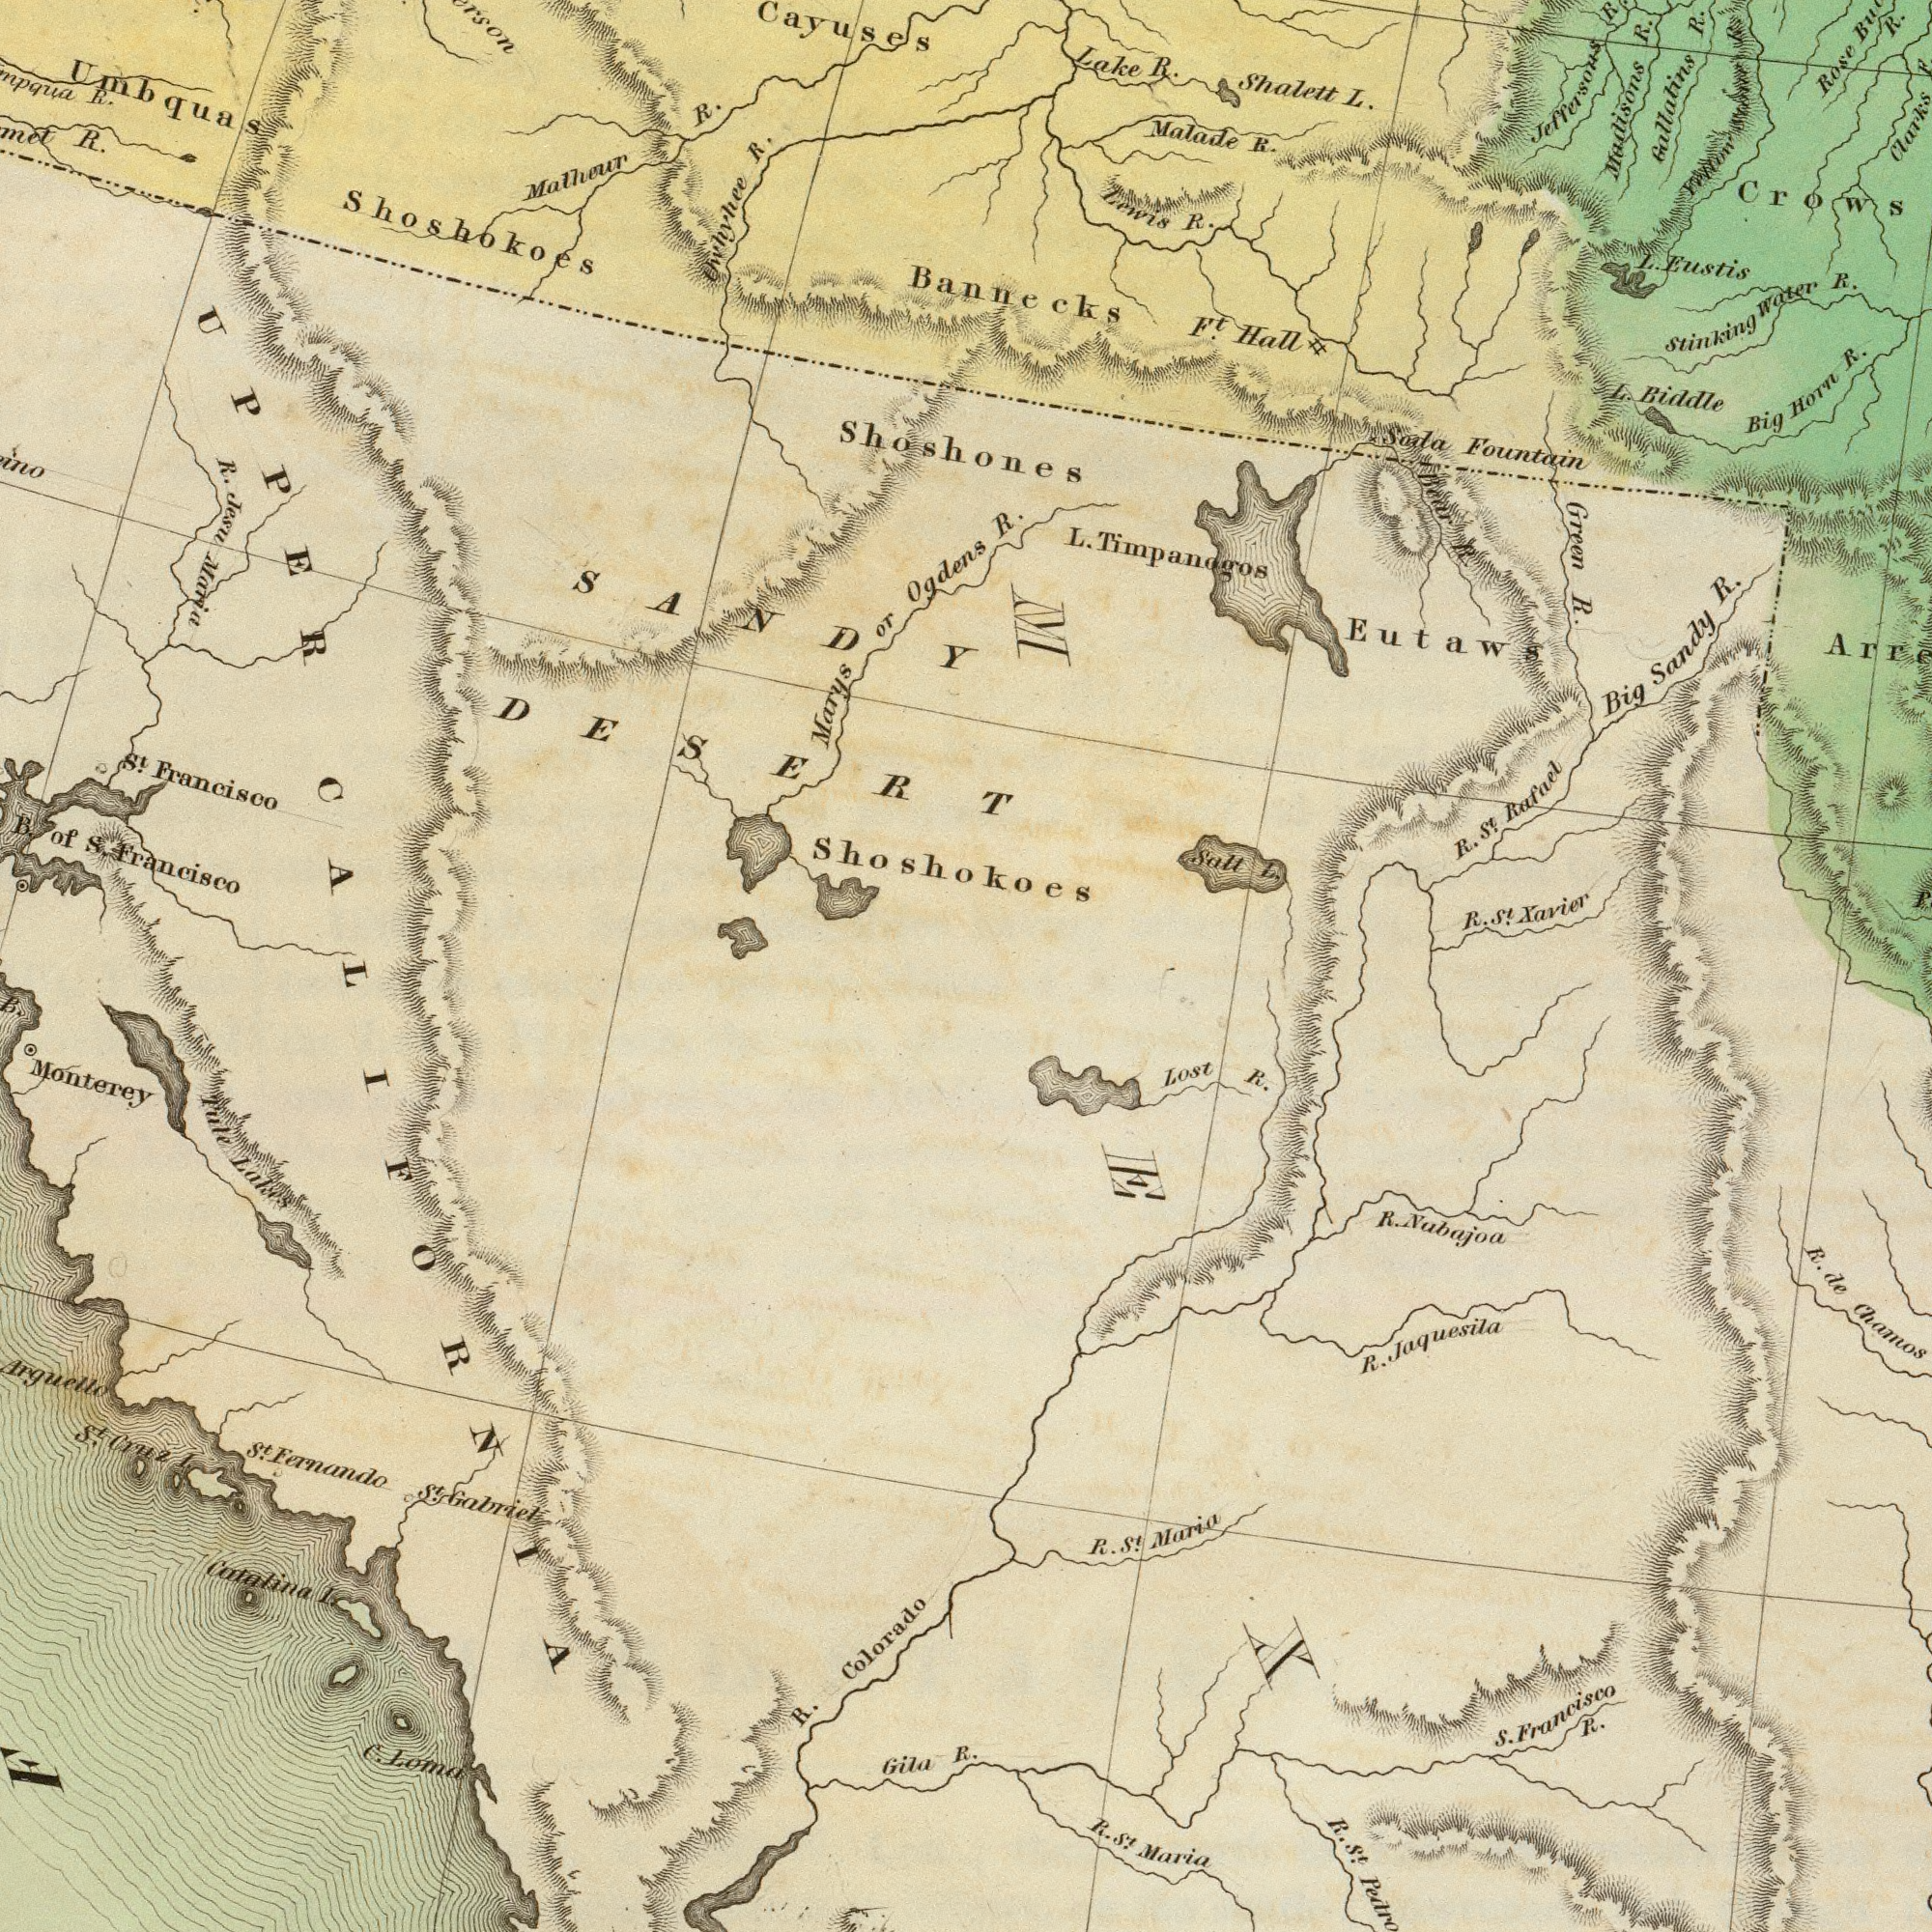What text can you see in the bottom-right section? S. Francisco R. Lost R. R. St. Maria R. de Chamos R. St. R. Nubajoa R. St. Maria R. Jaquesila What text appears in the top-right area of the image? R. Big Sandy R. Green R. Lake R. Eutaws L. Biddle L. Eustis Shalett L. Bannecks Big Horn R. Gallalins R. Malade R. Clarks R. Rose R. Lewis R. Soda Fountain R. St. Xavier Salt L. stinking Water R. L. Timpanagos Fft. Hall Bear R. R. St. Rafael Jeffersons Crows ###won R. Madisons R. What text is visible in the lower-left corner? CALIFORNIA Monterey Arguello R. Colorado Catalina I. St. Fernando Gila R. Fule Lakes C. Loma St. Cruz I. St. Galriel F What text is shown in the top-left quadrant? St. Francisco B. of S. Francisco R. Cayuses Malhour R. Uwhyhee R. R. Jesu Maria Shoshokoes Shoshokoes Umbquas SANDY DESERT R. Shoshones Marys or Ogdens UPPER 